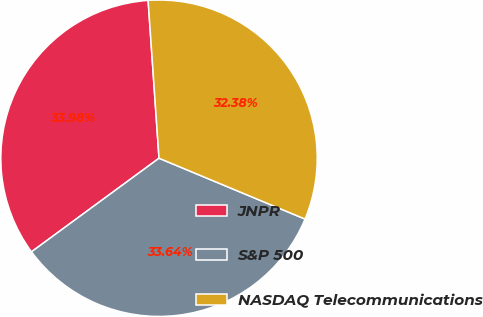<chart> <loc_0><loc_0><loc_500><loc_500><pie_chart><fcel>JNPR<fcel>S&P 500<fcel>NASDAQ Telecommunications<nl><fcel>33.98%<fcel>33.64%<fcel>32.38%<nl></chart> 